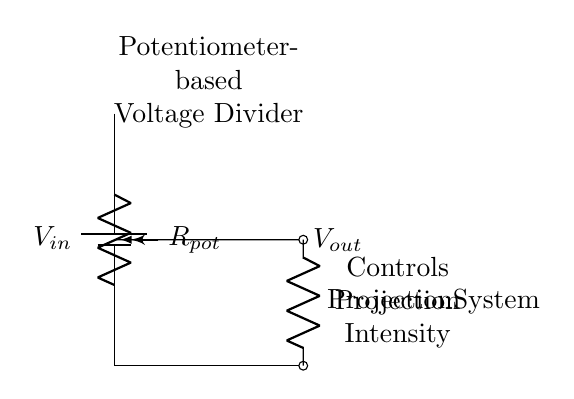What is the type of circuit represented? The circuit is a voltage divider as a potentiometer is used to divide voltage, controlling how much voltage is output.
Answer: Voltage Divider What component controls the projection intensity? The potentiometer serves as the variable resistor that adjusts the output voltage, thereby controlling the intensity of the projection system.
Answer: Potentiometer What is the output voltage taken from? The output voltage is taken from the middle point of the potentiometer, which connects to the projection system.
Answer: Wiper connection What is the role of the resistor labeled "Projection System"? The resistor represents the load (the projection system), across which the output voltage is measured and determines the power it receives.
Answer: Load resistor If the potentiometer is set to its minimum resistance, what is the expected output? At minimum resistance, most input voltage is dropped across the projection system, and the output will be lowest. The output approaches zero volts.
Answer: Zero volts How does changing the potentiometer affect voltage output? Adjusting the potentiometer changes its resistance, altering the division of input voltage based on the voltage divider rule, thereby increasing or decreasing the output voltage.
Answer: Varies output voltage What does the arrow on the potentiometer indicate? The arrow indicates the wiper's position, which is where the output voltage is taken from, effectively showing the adjustment point of the potentiometer.
Answer: Wiper position 